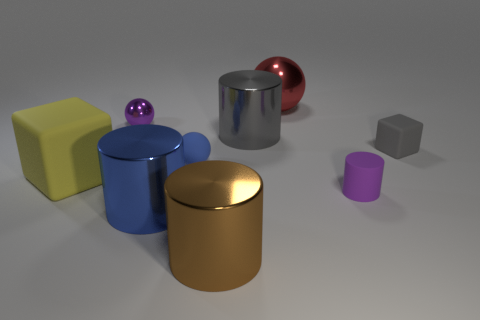Subtract all small spheres. How many spheres are left? 1 Add 1 yellow things. How many objects exist? 10 Subtract all blue cylinders. How many cylinders are left? 3 Subtract all balls. How many objects are left? 6 Subtract all gray cylinders. Subtract all green cubes. How many cylinders are left? 3 Subtract all brown metallic objects. Subtract all tiny purple metallic objects. How many objects are left? 7 Add 4 large things. How many large things are left? 9 Add 1 large blue shiny cylinders. How many large blue shiny cylinders exist? 2 Subtract 0 yellow cylinders. How many objects are left? 9 